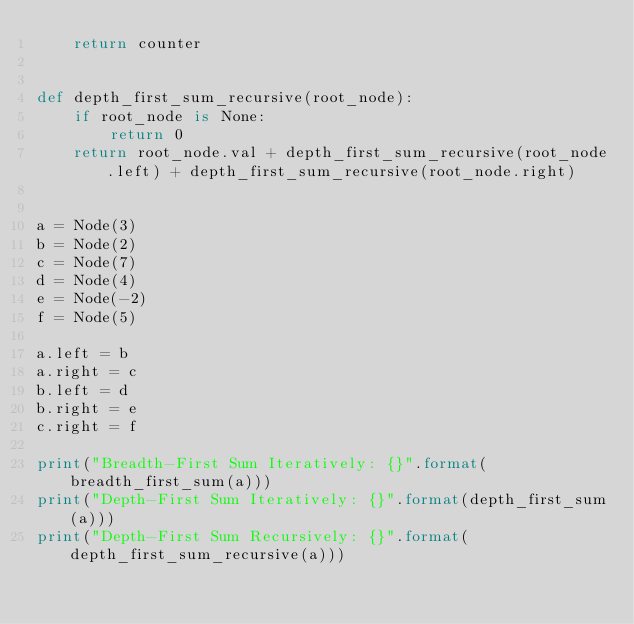Convert code to text. <code><loc_0><loc_0><loc_500><loc_500><_Python_>    return counter


def depth_first_sum_recursive(root_node):
    if root_node is None:
        return 0
    return root_node.val + depth_first_sum_recursive(root_node.left) + depth_first_sum_recursive(root_node.right)


a = Node(3)
b = Node(2)
c = Node(7)
d = Node(4)
e = Node(-2)
f = Node(5)

a.left = b
a.right = c
b.left = d
b.right = e
c.right = f

print("Breadth-First Sum Iteratively: {}".format(breadth_first_sum(a)))
print("Depth-First Sum Iteratively: {}".format(depth_first_sum(a)))
print("Depth-First Sum Recursively: {}".format(depth_first_sum_recursive(a)))</code> 